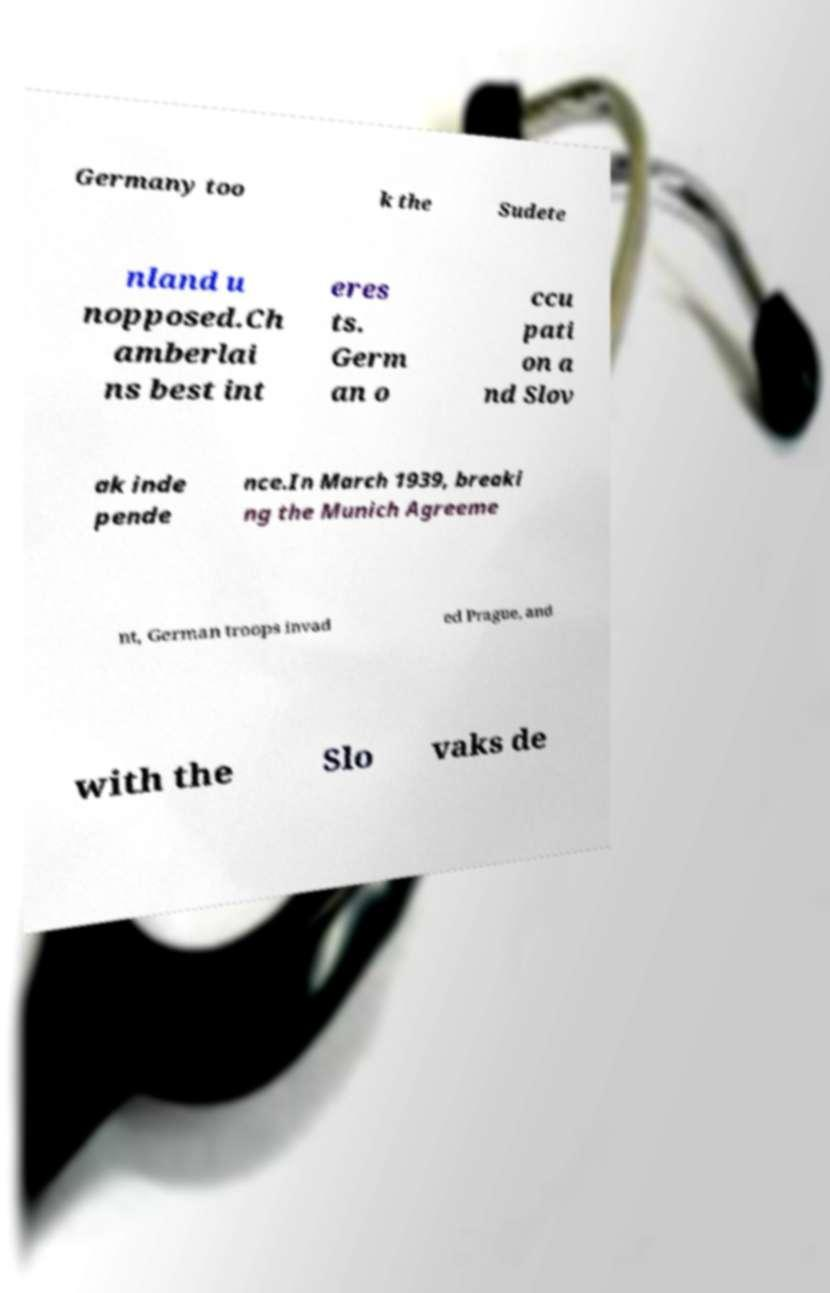There's text embedded in this image that I need extracted. Can you transcribe it verbatim? Germany too k the Sudete nland u nopposed.Ch amberlai ns best int eres ts. Germ an o ccu pati on a nd Slov ak inde pende nce.In March 1939, breaki ng the Munich Agreeme nt, German troops invad ed Prague, and with the Slo vaks de 